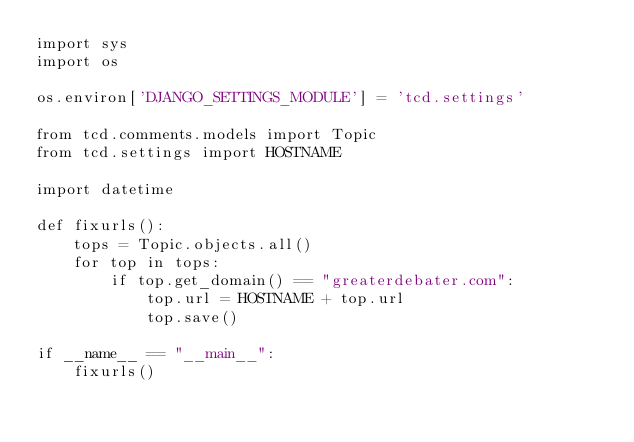Convert code to text. <code><loc_0><loc_0><loc_500><loc_500><_Python_>import sys
import os

os.environ['DJANGO_SETTINGS_MODULE'] = 'tcd.settings'

from tcd.comments.models import Topic
from tcd.settings import HOSTNAME

import datetime

def fixurls():
    tops = Topic.objects.all()
    for top in tops:
        if top.get_domain() == "greaterdebater.com":
            top.url = HOSTNAME + top.url
            top.save()

if __name__ == "__main__":
    fixurls()
</code> 